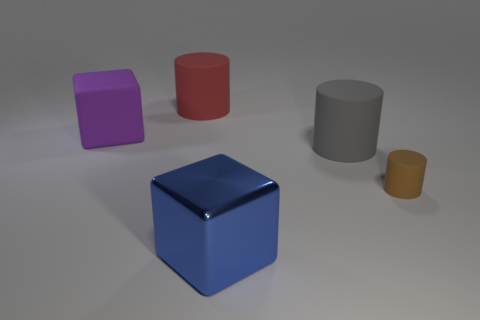Are there any other things that are the same material as the big blue block?
Make the answer very short. No. Is there any other thing that is the same size as the brown cylinder?
Provide a succinct answer. No. There is a large object that is both left of the gray rubber object and to the right of the red matte object; what is its shape?
Offer a terse response. Cube. Is there a large blue cube that is to the left of the big cube that is to the left of the large object that is behind the purple matte block?
Ensure brevity in your answer.  No. What number of other things are there of the same material as the gray cylinder
Give a very brief answer. 3. How many red objects are there?
Provide a succinct answer. 1. How many objects are either small green cylinders or matte cylinders that are in front of the gray matte thing?
Provide a succinct answer. 1. Are there any other things that have the same shape as the tiny rubber object?
Provide a succinct answer. Yes. There is a block in front of the purple cube; is its size the same as the red cylinder?
Offer a very short reply. Yes. How many rubber things are blue cubes or gray cylinders?
Your answer should be compact. 1. 